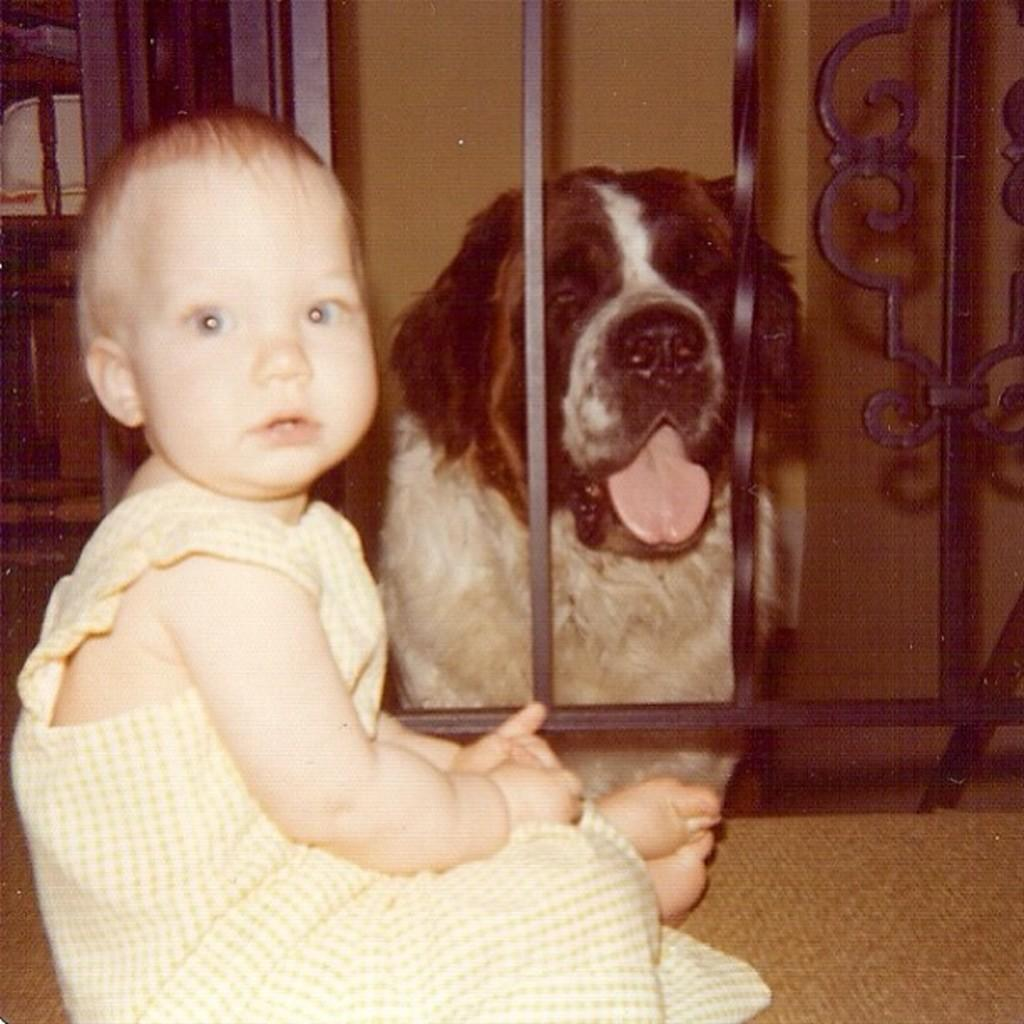What is the main subject of the image? The main subject of the image is a kid sitting. What other living creature is present in the image? There is a dog in the image. What type of architectural feature can be seen in the image? There are iron grilles in the image. What is visible in the background of the image? There is a wall in the background of the image. How much honey is the judge pouring for the kid in the image? There is no judge or honey present in the image. What type of aunt is sitting with the kid in the image? There is no aunt present in the image; it only features a kid sitting and a dog. 